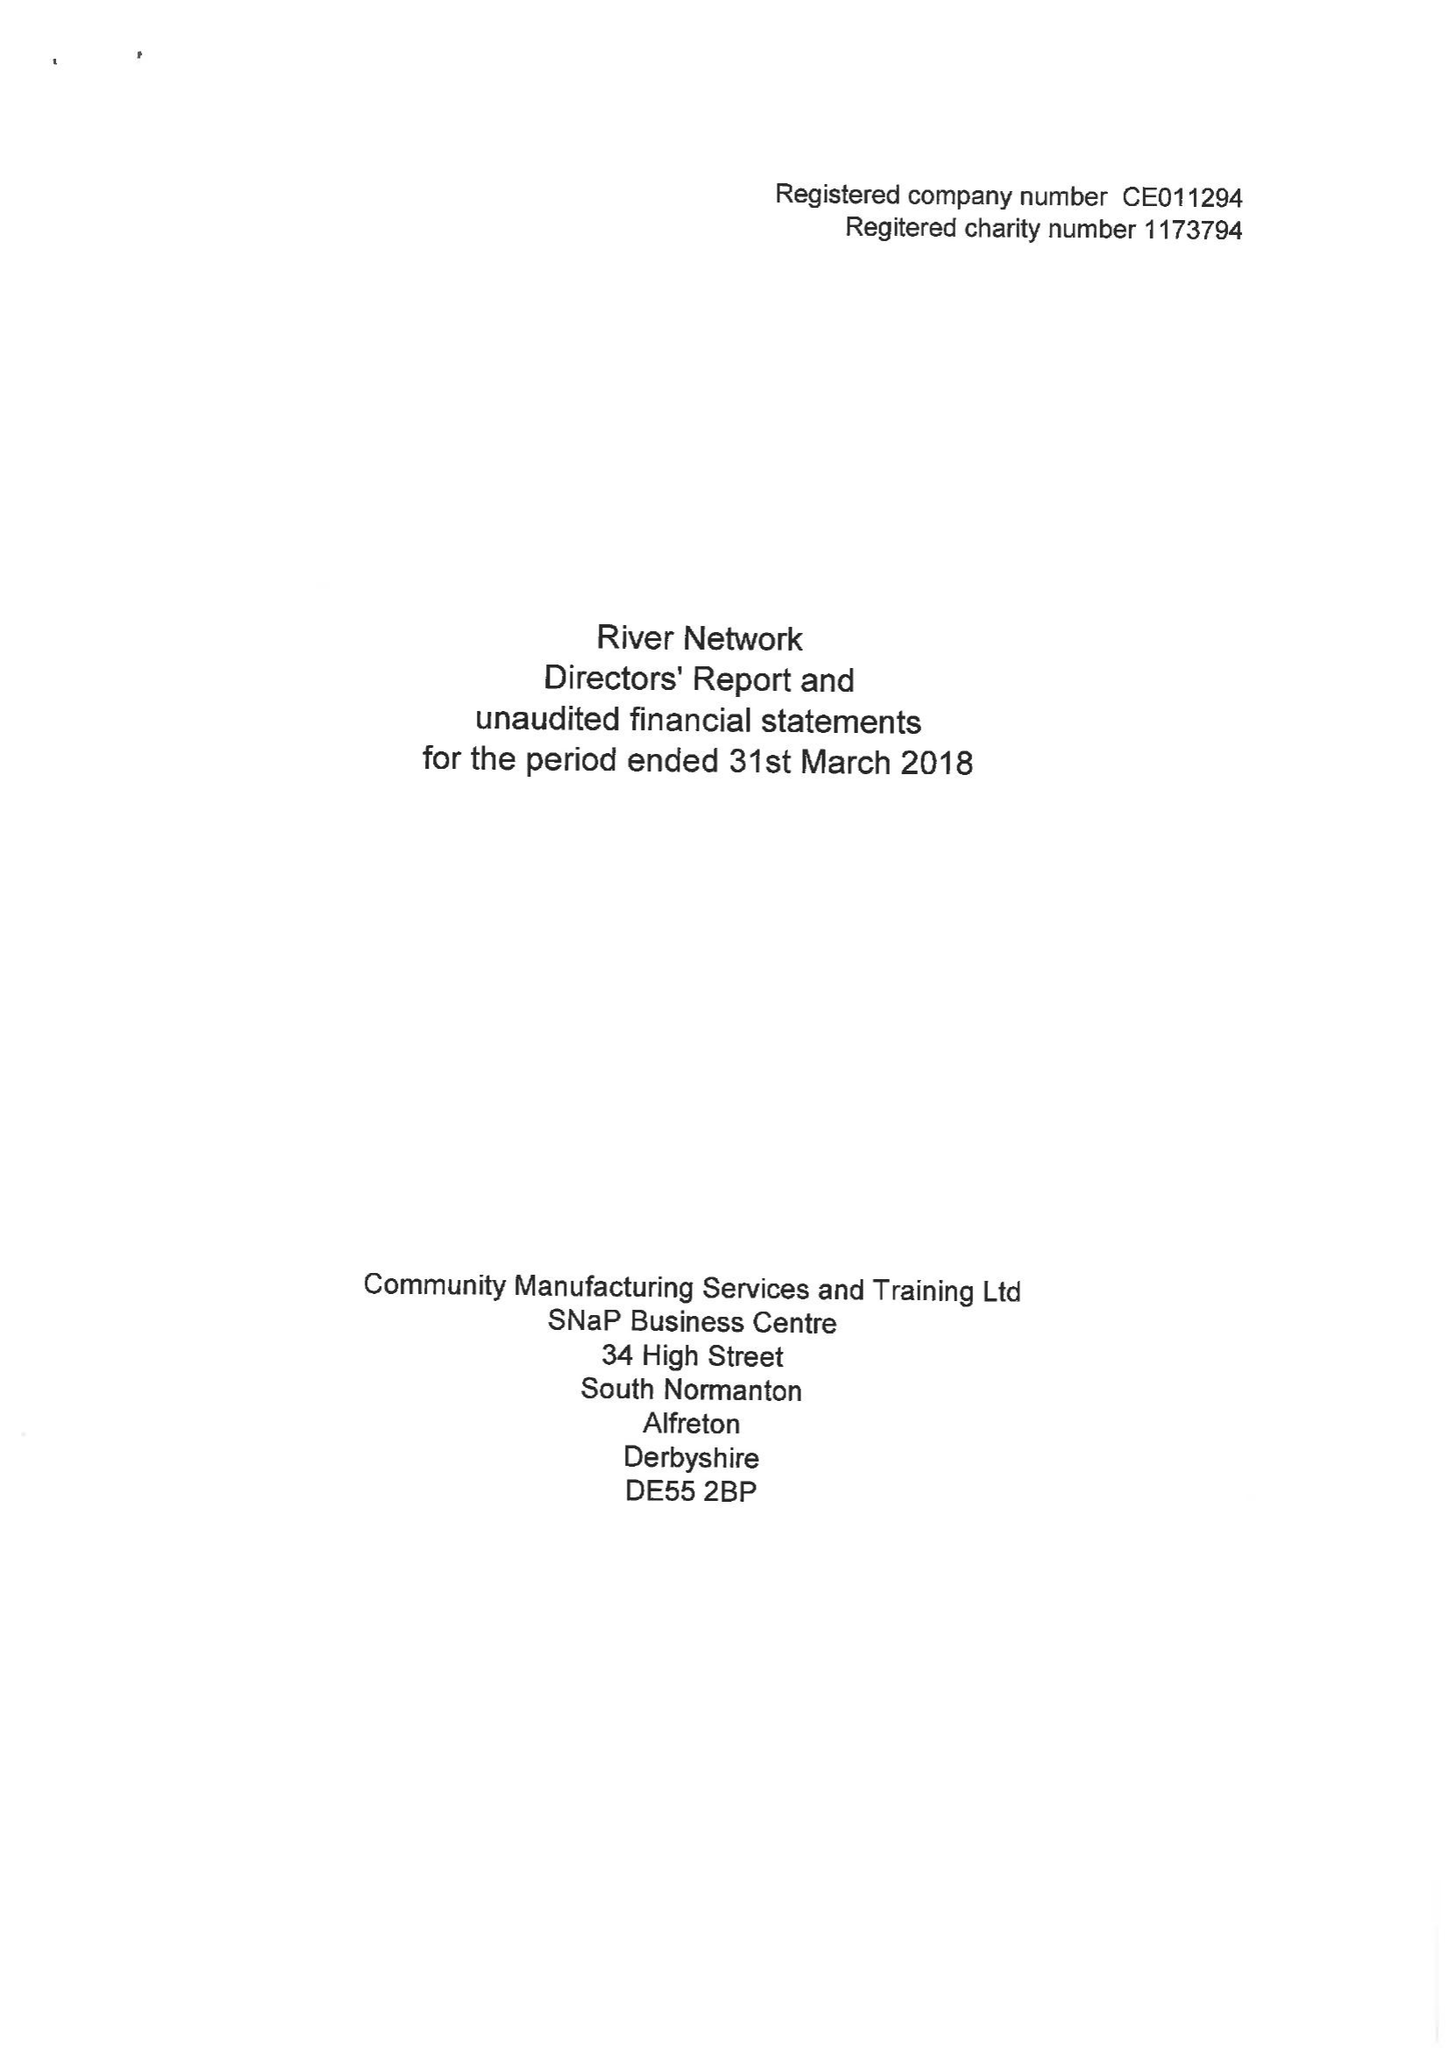What is the value for the charity_name?
Answer the question using a single word or phrase. River Network 